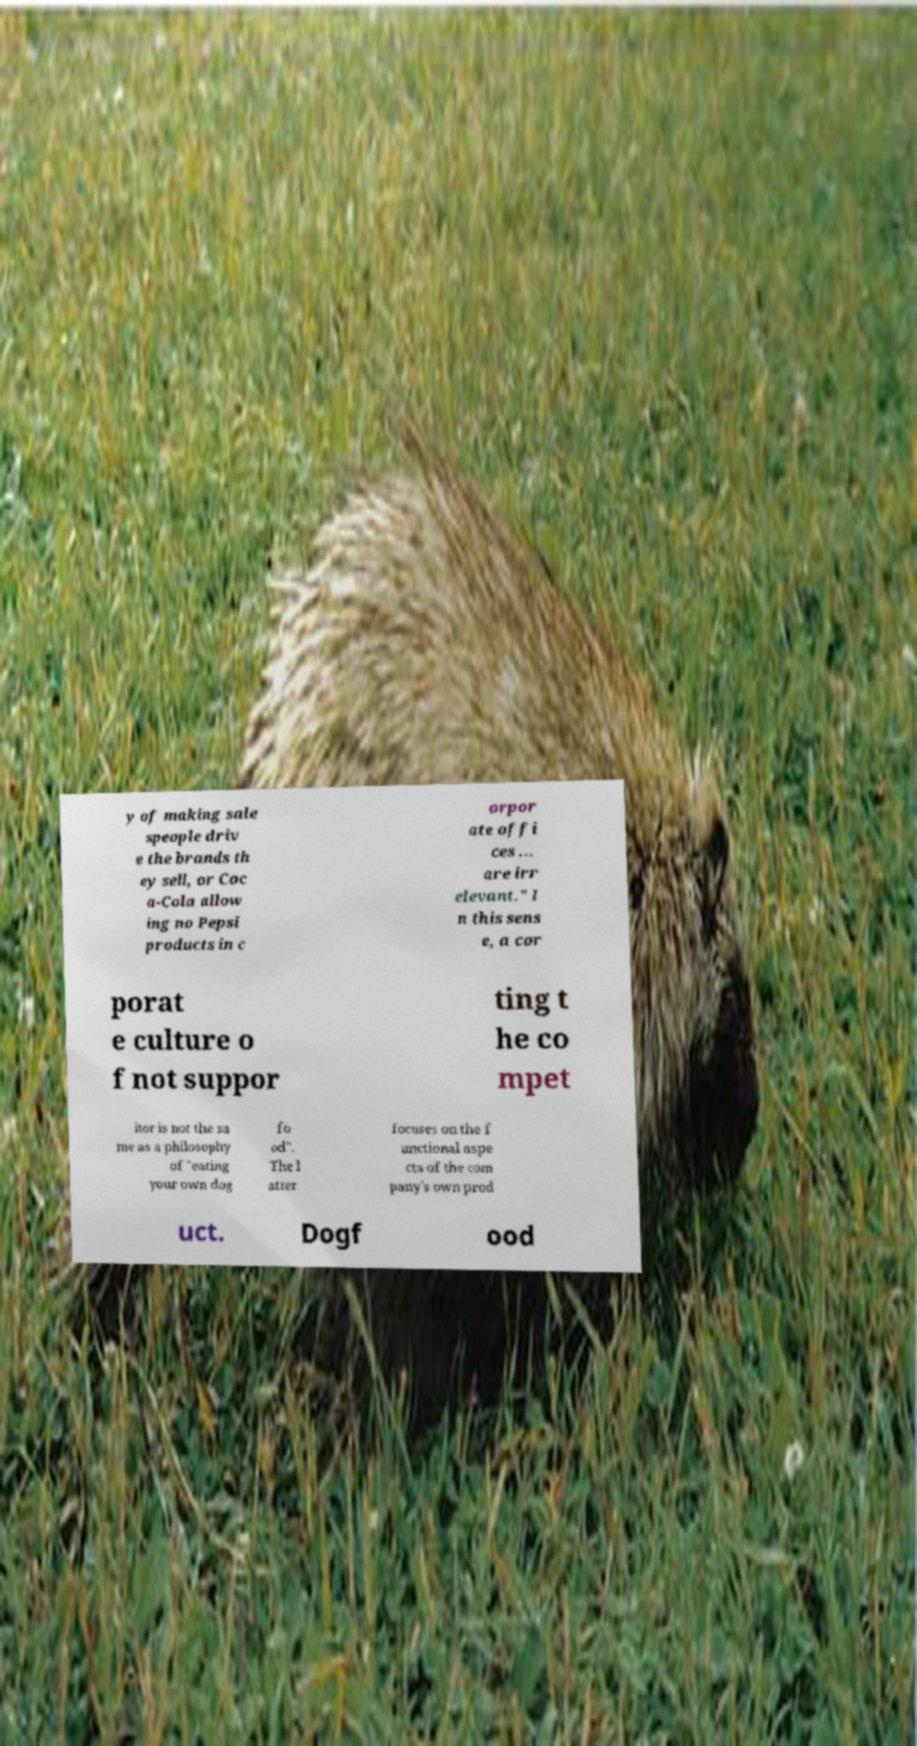Please identify and transcribe the text found in this image. y of making sale speople driv e the brands th ey sell, or Coc a-Cola allow ing no Pepsi products in c orpor ate offi ces ... are irr elevant." I n this sens e, a cor porat e culture o f not suppor ting t he co mpet itor is not the sa me as a philosophy of "eating your own dog fo od". The l atter focuses on the f unctional aspe cts of the com pany's own prod uct. Dogf ood 